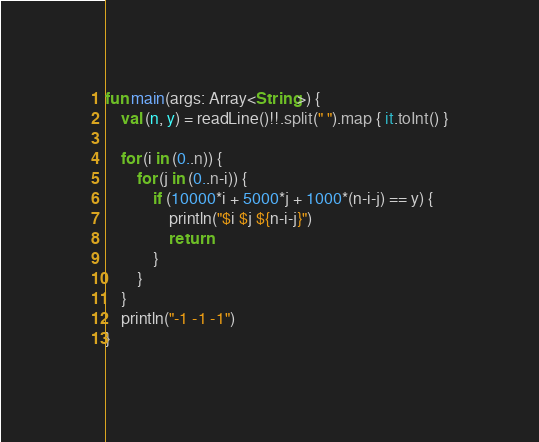<code> <loc_0><loc_0><loc_500><loc_500><_Kotlin_>fun main(args: Array<String>) {
    val (n, y) = readLine()!!.split(" ").map { it.toInt() }

    for (i in (0..n)) {
        for (j in (0..n-i)) {
            if (10000*i + 5000*j + 1000*(n-i-j) == y) {
                println("$i $j ${n-i-j}")
                return
            }
        }
    }
    println("-1 -1 -1")
}</code> 